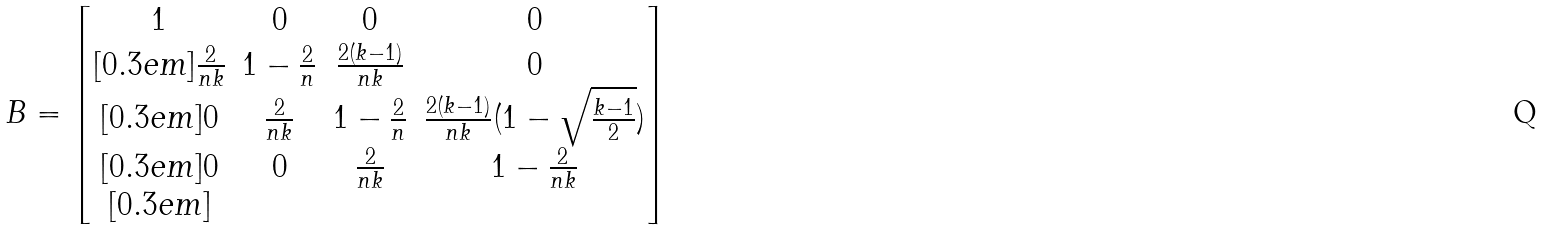<formula> <loc_0><loc_0><loc_500><loc_500>B = \begin{bmatrix} 1 & 0 & 0 & 0 \\ [ 0 . 3 e m ] \frac { 2 } { n k } & 1 - \frac { 2 } { n } & \frac { 2 ( k - 1 ) } { n k } & 0 \\ [ 0 . 3 e m ] 0 & \frac { 2 } { n k } & 1 - \frac { 2 } { n } & \frac { 2 ( k - 1 ) } { n k } ( 1 - \sqrt { \frac { k - 1 } { 2 } } ) \\ [ 0 . 3 e m ] 0 & 0 & \frac { 2 } { n k } & 1 - \frac { 2 } { n k } \\ [ 0 . 3 e m ] \end{bmatrix}</formula> 